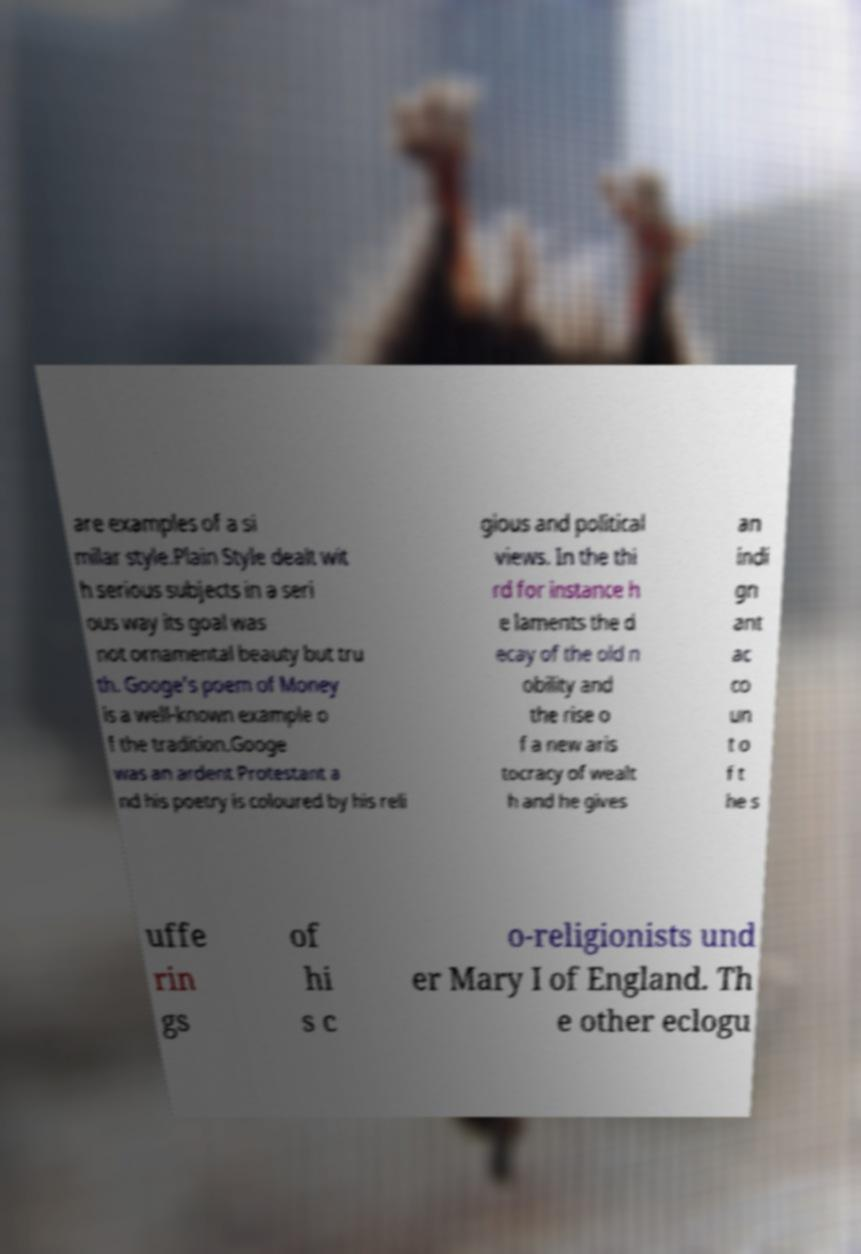Can you read and provide the text displayed in the image?This photo seems to have some interesting text. Can you extract and type it out for me? are examples of a si milar style.Plain Style dealt wit h serious subjects in a seri ous way its goal was not ornamental beauty but tru th. Googe's poem of Money is a well-known example o f the tradition.Googe was an ardent Protestant a nd his poetry is coloured by his reli gious and political views. In the thi rd for instance h e laments the d ecay of the old n obility and the rise o f a new aris tocracy of wealt h and he gives an indi gn ant ac co un t o f t he s uffe rin gs of hi s c o-religionists und er Mary I of England. Th e other eclogu 